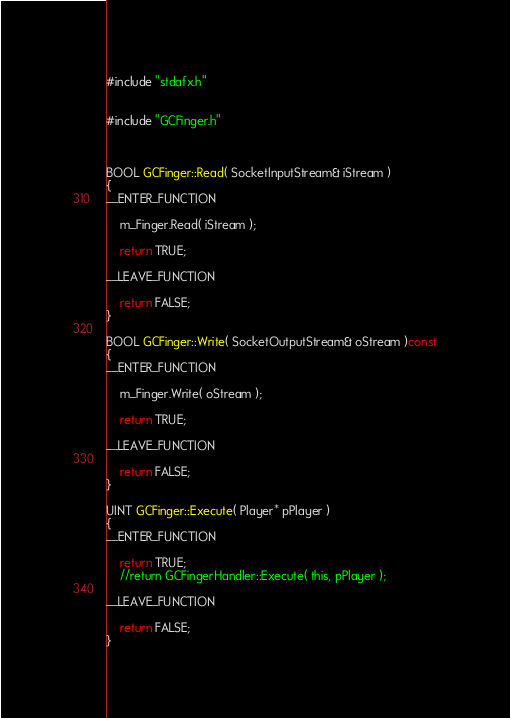<code> <loc_0><loc_0><loc_500><loc_500><_C++_>#include "stdafx.h"


#include "GCFinger.h"



BOOL GCFinger::Read( SocketInputStream& iStream ) 
{
__ENTER_FUNCTION

    m_Finger.Read( iStream );

    return TRUE;

__LEAVE_FUNCTION

    return FALSE;
}

BOOL GCFinger::Write( SocketOutputStream& oStream )const
{
__ENTER_FUNCTION

    m_Finger.Write( oStream );

    return TRUE;

__LEAVE_FUNCTION

    return FALSE;
}

UINT GCFinger::Execute( Player* pPlayer )
{
__ENTER_FUNCTION

    return TRUE;
    //return GCFingerHandler::Execute( this, pPlayer );

__LEAVE_FUNCTION

    return FALSE;
}


</code> 